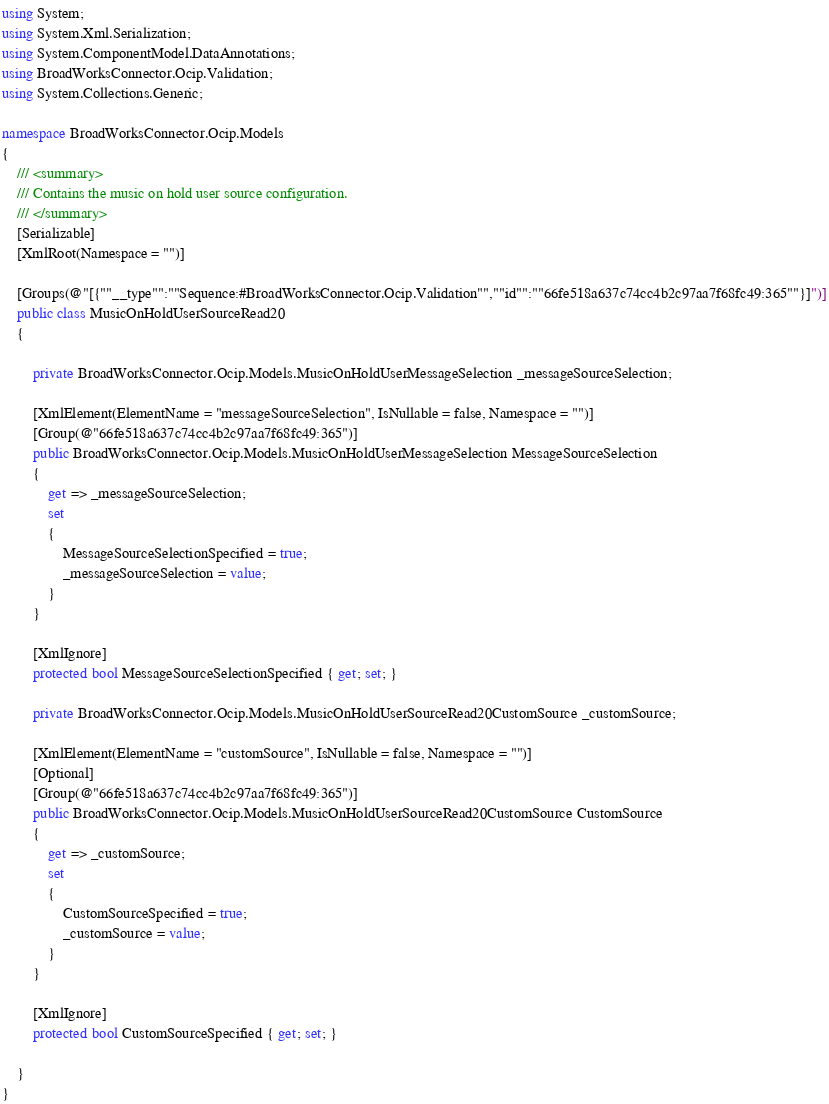Convert code to text. <code><loc_0><loc_0><loc_500><loc_500><_C#_>using System;
using System.Xml.Serialization;
using System.ComponentModel.DataAnnotations;
using BroadWorksConnector.Ocip.Validation;
using System.Collections.Generic;

namespace BroadWorksConnector.Ocip.Models
{
    /// <summary>
    /// Contains the music on hold user source configuration.
    /// </summary>
    [Serializable]
    [XmlRoot(Namespace = "")]

    [Groups(@"[{""__type"":""Sequence:#BroadWorksConnector.Ocip.Validation"",""id"":""66fe518a637c74cc4b2c97aa7f68fc49:365""}]")]
    public class MusicOnHoldUserSourceRead20
    {

        private BroadWorksConnector.Ocip.Models.MusicOnHoldUserMessageSelection _messageSourceSelection;

        [XmlElement(ElementName = "messageSourceSelection", IsNullable = false, Namespace = "")]
        [Group(@"66fe518a637c74cc4b2c97aa7f68fc49:365")]
        public BroadWorksConnector.Ocip.Models.MusicOnHoldUserMessageSelection MessageSourceSelection
        {
            get => _messageSourceSelection;
            set
            {
                MessageSourceSelectionSpecified = true;
                _messageSourceSelection = value;
            }
        }

        [XmlIgnore]
        protected bool MessageSourceSelectionSpecified { get; set; }

        private BroadWorksConnector.Ocip.Models.MusicOnHoldUserSourceRead20CustomSource _customSource;

        [XmlElement(ElementName = "customSource", IsNullable = false, Namespace = "")]
        [Optional]
        [Group(@"66fe518a637c74cc4b2c97aa7f68fc49:365")]
        public BroadWorksConnector.Ocip.Models.MusicOnHoldUserSourceRead20CustomSource CustomSource
        {
            get => _customSource;
            set
            {
                CustomSourceSpecified = true;
                _customSource = value;
            }
        }

        [XmlIgnore]
        protected bool CustomSourceSpecified { get; set; }

    }
}
</code> 